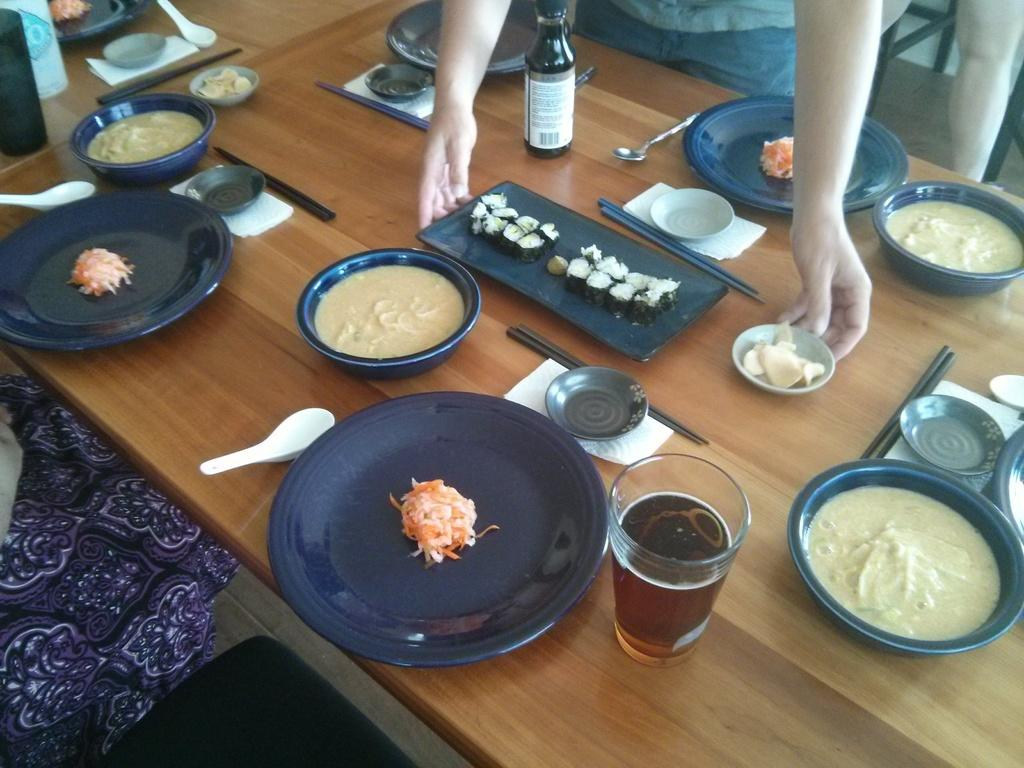What type of objects can be seen on the table in the image? There are balls, bowls containing food, plates, glasses, and a bottle on the table in the image. What might be used for holding or serving food in the image? The bowls and plates in the image can be used for holding or serving food. What can be used for drinking in the image? A: The glasses in the image can be used for drinking. What might be used for pouring a beverage in the image? The bottle in the image can be used for pouring a beverage. Where are the giants sitting in the image? There are no giants present in the image. What type of writing instrument is on the shelf in the image? There is no shelf or quill present in the image. 